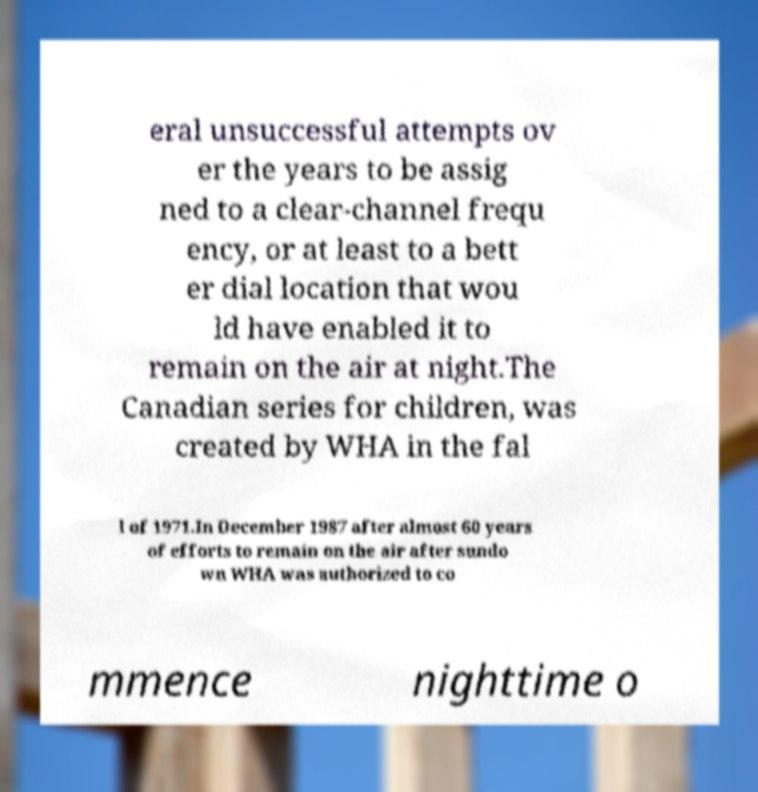I need the written content from this picture converted into text. Can you do that? eral unsuccessful attempts ov er the years to be assig ned to a clear-channel frequ ency, or at least to a bett er dial location that wou ld have enabled it to remain on the air at night.The Canadian series for children, was created by WHA in the fal l of 1971.In December 1987 after almost 60 years of efforts to remain on the air after sundo wn WHA was authorized to co mmence nighttime o 